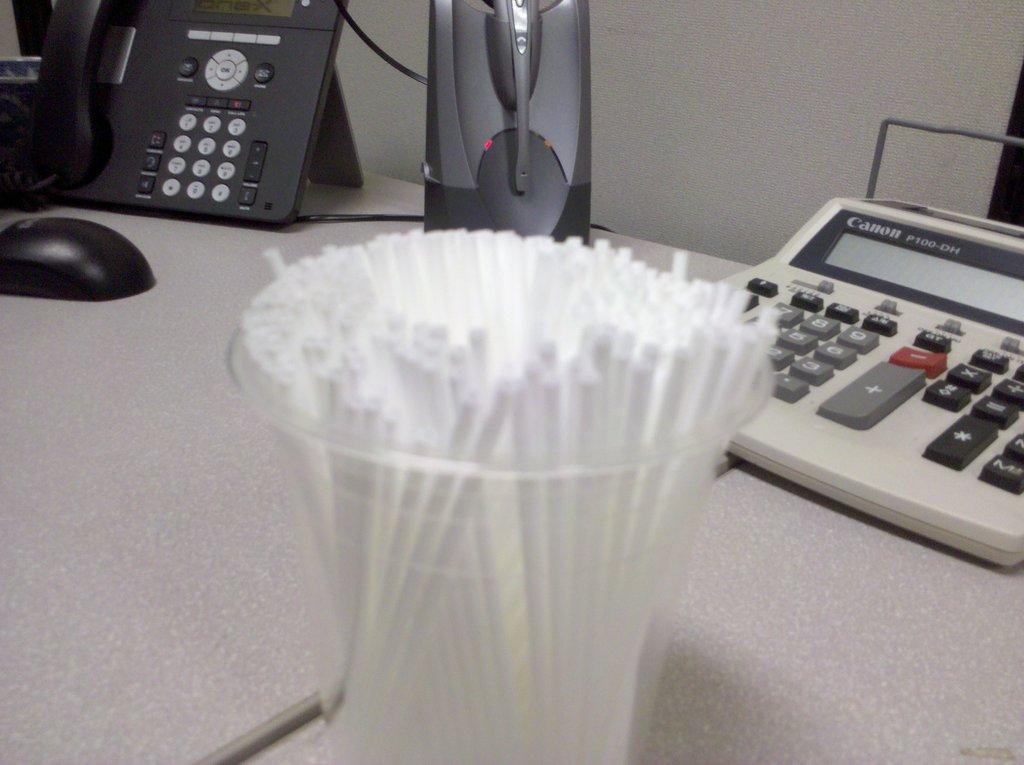<image>
Present a compact description of the photo's key features. An old adding machine made by Canon sits at the back of the desk. 